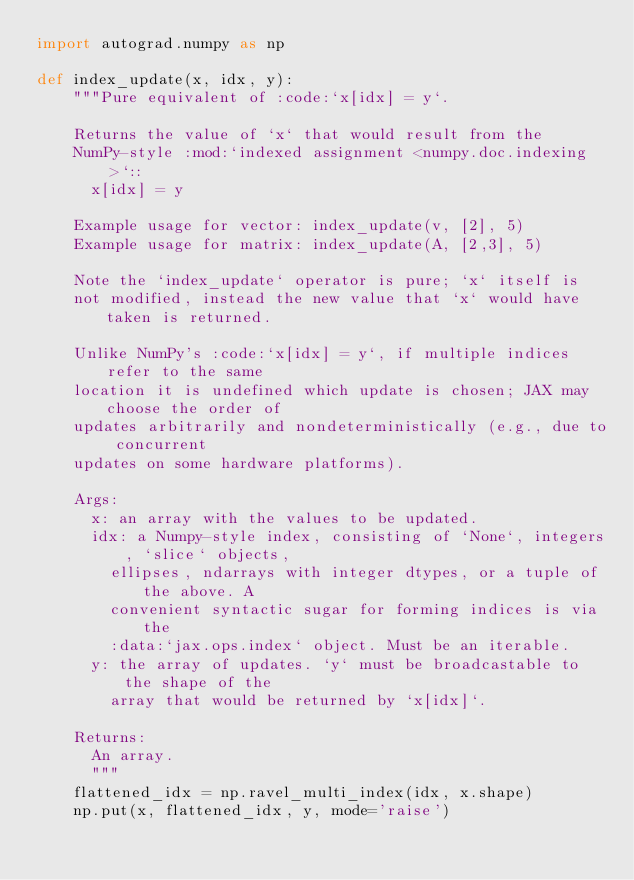Convert code to text. <code><loc_0><loc_0><loc_500><loc_500><_Python_>import autograd.numpy as np

def index_update(x, idx, y):
    """Pure equivalent of :code:`x[idx] = y`.

    Returns the value of `x` that would result from the
    NumPy-style :mod:`indexed assignment <numpy.doc.indexing>`::
      x[idx] = y

    Example usage for vector: index_update(v, [2], 5)
    Example usage for matrix: index_update(A, [2,3], 5)

    Note the `index_update` operator is pure; `x` itself is
    not modified, instead the new value that `x` would have taken is returned.

    Unlike NumPy's :code:`x[idx] = y`, if multiple indices refer to the same
    location it is undefined which update is chosen; JAX may choose the order of
    updates arbitrarily and nondeterministically (e.g., due to concurrent
    updates on some hardware platforms).

    Args:
      x: an array with the values to be updated.
      idx: a Numpy-style index, consisting of `None`, integers, `slice` objects,
        ellipses, ndarrays with integer dtypes, or a tuple of the above. A
        convenient syntactic sugar for forming indices is via the
        :data:`jax.ops.index` object. Must be an iterable.
      y: the array of updates. `y` must be broadcastable to the shape of the
        array that would be returned by `x[idx]`.

    Returns:
      An array.
      """
    flattened_idx = np.ravel_multi_index(idx, x.shape)
    np.put(x, flattened_idx, y, mode='raise')</code> 